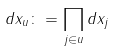Convert formula to latex. <formula><loc_0><loc_0><loc_500><loc_500>d x _ { u } \colon = \prod _ { j \in u } d x _ { j }</formula> 